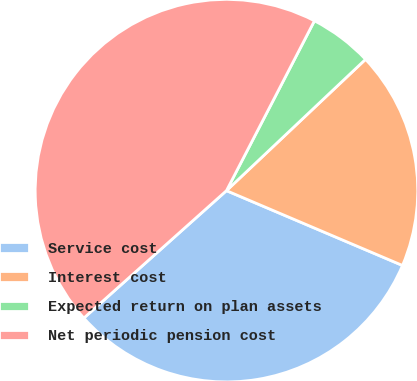Convert chart to OTSL. <chart><loc_0><loc_0><loc_500><loc_500><pie_chart><fcel>Service cost<fcel>Interest cost<fcel>Expected return on plan assets<fcel>Net periodic pension cost<nl><fcel>32.0%<fcel>18.44%<fcel>5.35%<fcel>44.21%<nl></chart> 